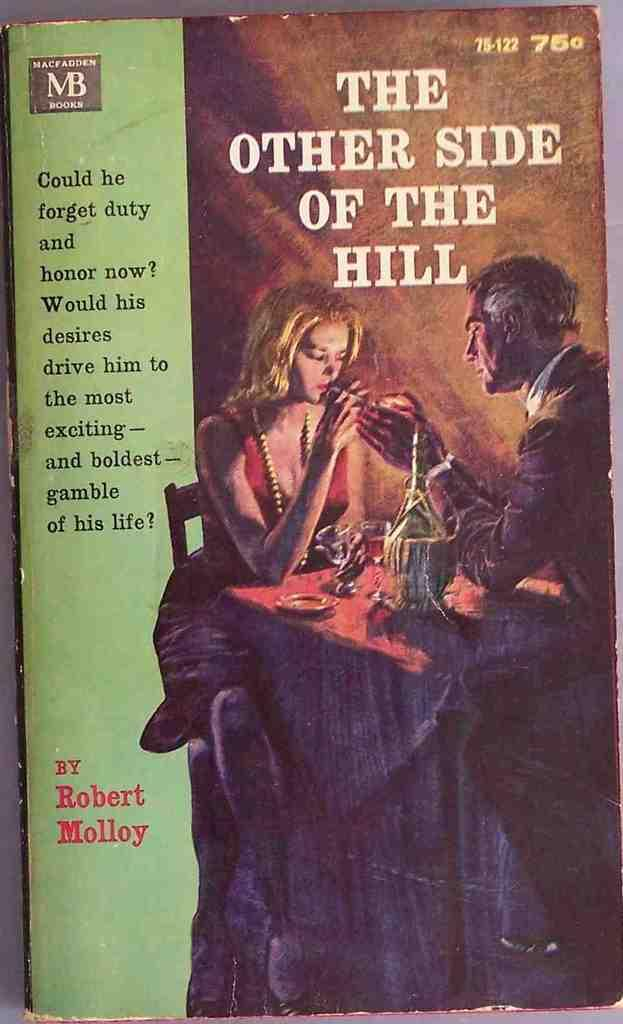Provide a one-sentence caption for the provided image. A book titled The Other Side of the Hill showing a man and a women sitting at a table. 